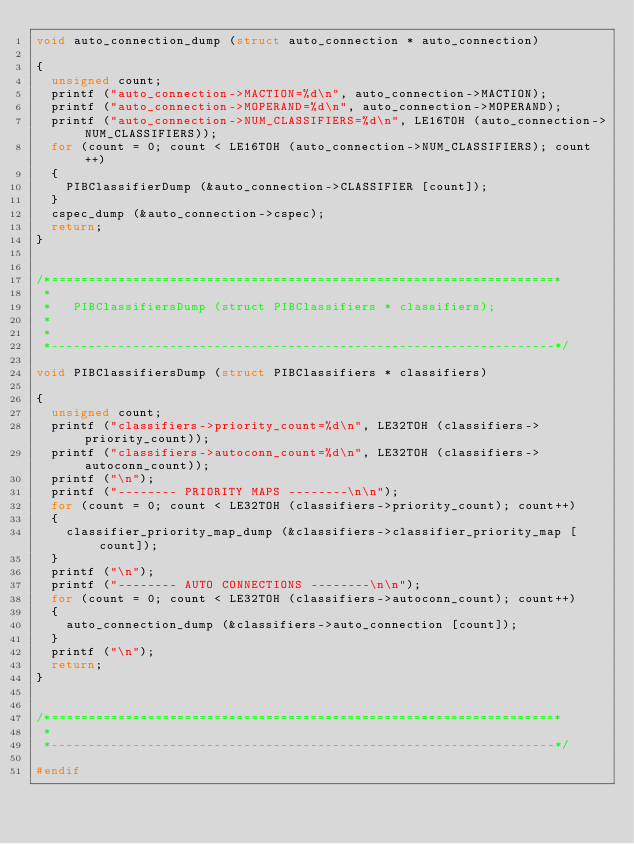Convert code to text. <code><loc_0><loc_0><loc_500><loc_500><_C_>void auto_connection_dump (struct auto_connection * auto_connection)

{
	unsigned count;
	printf ("auto_connection->MACTION=%d\n", auto_connection->MACTION);
	printf ("auto_connection->MOPERAND=%d\n", auto_connection->MOPERAND);
	printf ("auto_connection->NUM_CLASSIFIERS=%d\n", LE16TOH (auto_connection->NUM_CLASSIFIERS));
	for (count = 0; count < LE16TOH (auto_connection->NUM_CLASSIFIERS); count++)
	{
		PIBClassifierDump (&auto_connection->CLASSIFIER [count]);
	}
	cspec_dump (&auto_connection->cspec);
	return;
}


/*====================================================================*
 *
 *   PIBClassifiersDump (struct PIBClassifiers * classifiers);
 *
 *
 *--------------------------------------------------------------------*/

void PIBClassifiersDump (struct PIBClassifiers * classifiers)

{
	unsigned count;
	printf ("classifiers->priority_count=%d\n", LE32TOH (classifiers->priority_count));
	printf ("classifiers->autoconn_count=%d\n", LE32TOH (classifiers->autoconn_count));
	printf ("\n");
	printf ("-------- PRIORITY MAPS --------\n\n");
	for (count = 0; count < LE32TOH (classifiers->priority_count); count++)
	{
		classifier_priority_map_dump (&classifiers->classifier_priority_map [count]);
	}
	printf ("\n");
	printf ("-------- AUTO CONNECTIONS --------\n\n");
	for (count = 0; count < LE32TOH (classifiers->autoconn_count); count++)
	{
		auto_connection_dump (&classifiers->auto_connection [count]);
	}
	printf ("\n");
	return;
}


/*====================================================================*
 *
 *--------------------------------------------------------------------*/

#endif

</code> 